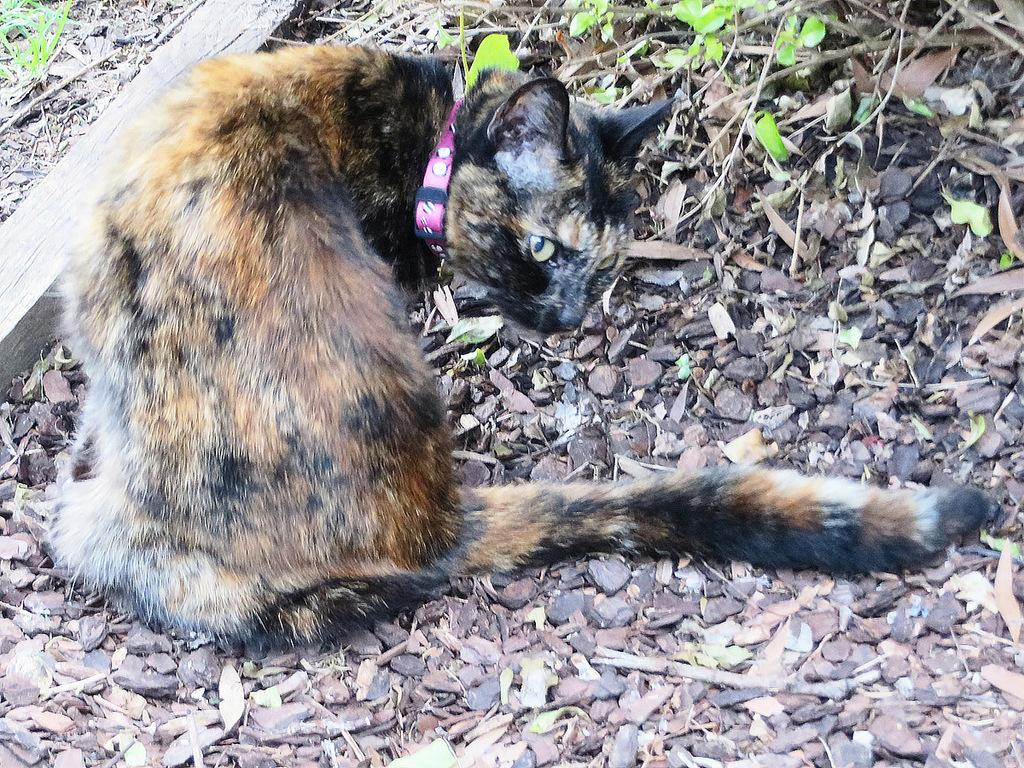What type of animal is in the image? There is a cat in the image. What can be seen in the background of the image? There are plants, twigs, stones, grass, and other objects in the background of the image. How many pieces of cheese are on the cat's whiskers in the image? There is no cheese present in the image, and therefore no cheese on the cat's whiskers. How many kittens are playing with the cat in the image? There is only one cat visible in the image, and no kittens are present. 